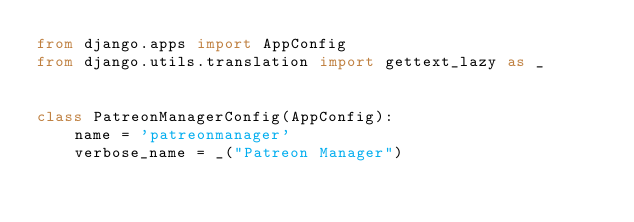<code> <loc_0><loc_0><loc_500><loc_500><_Python_>from django.apps import AppConfig
from django.utils.translation import gettext_lazy as _


class PatreonManagerConfig(AppConfig):
    name = 'patreonmanager'
    verbose_name = _("Patreon Manager")
</code> 